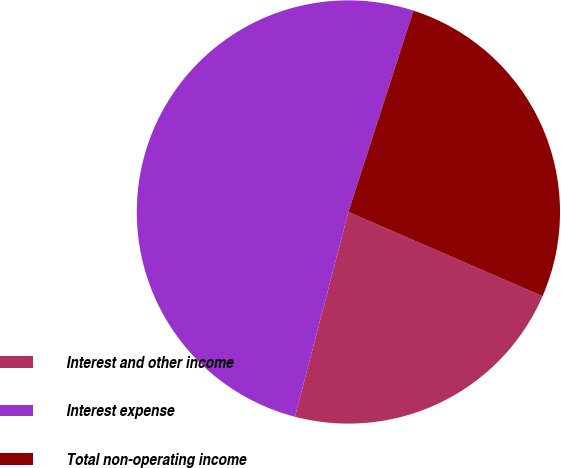<chart> <loc_0><loc_0><loc_500><loc_500><pie_chart><fcel>Interest and other income<fcel>Interest expense<fcel>Total non-operating income<nl><fcel>22.55%<fcel>50.91%<fcel>26.54%<nl></chart> 